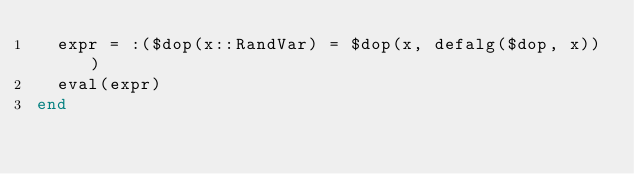<code> <loc_0><loc_0><loc_500><loc_500><_Julia_>  expr = :($dop(x::RandVar) = $dop(x, defalg($dop, x)))
  eval(expr)
end
</code> 